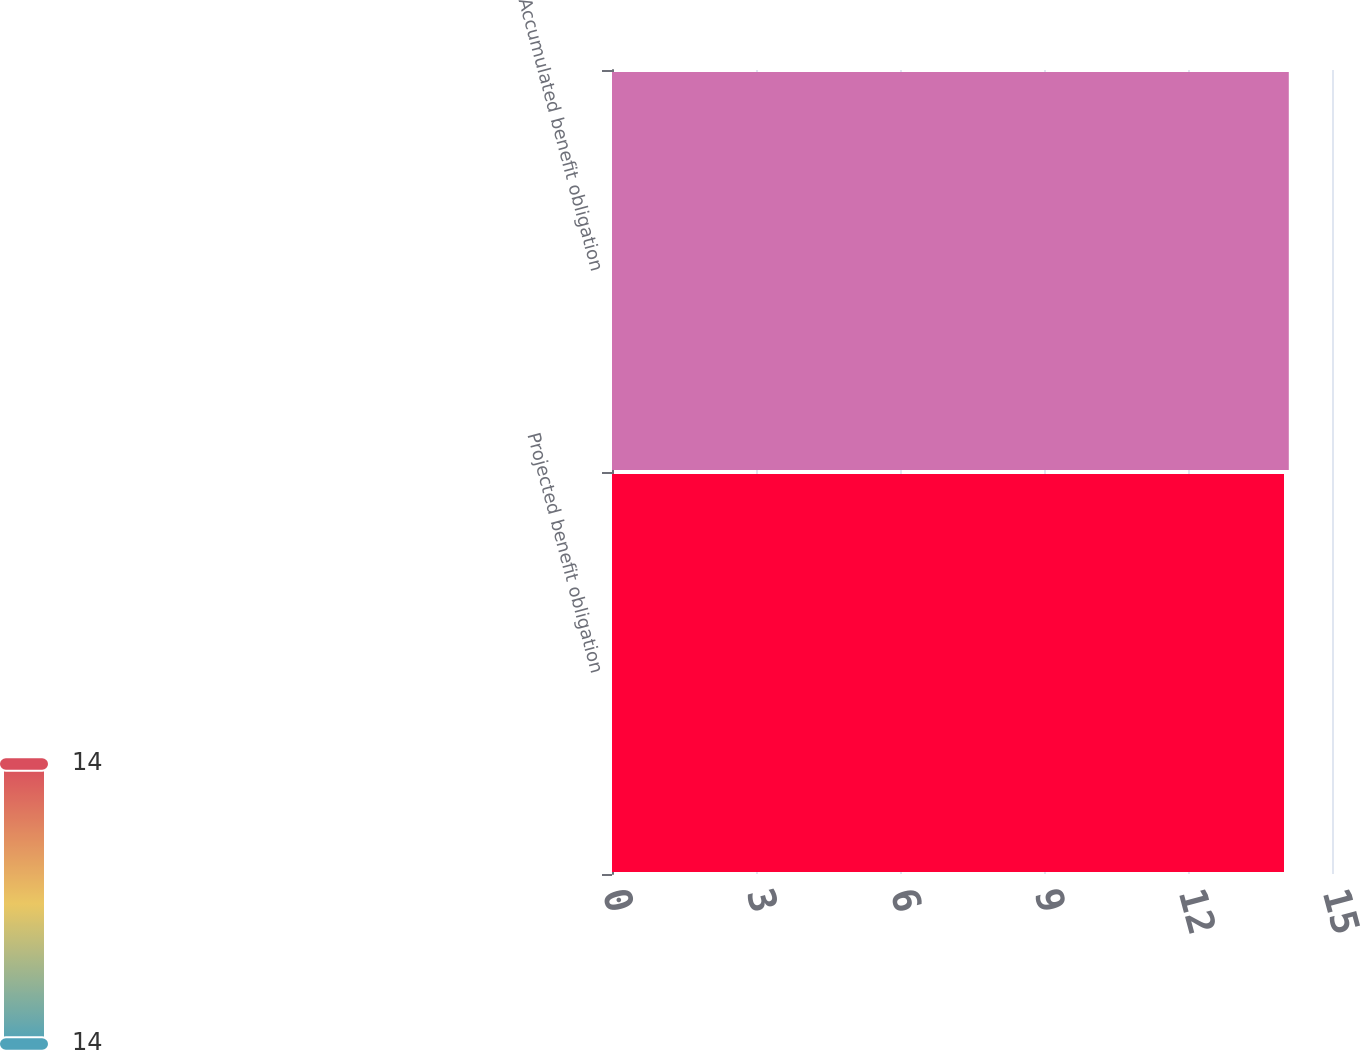Convert chart to OTSL. <chart><loc_0><loc_0><loc_500><loc_500><bar_chart><fcel>Projected benefit obligation<fcel>Accumulated benefit obligation<nl><fcel>14<fcel>14.1<nl></chart> 